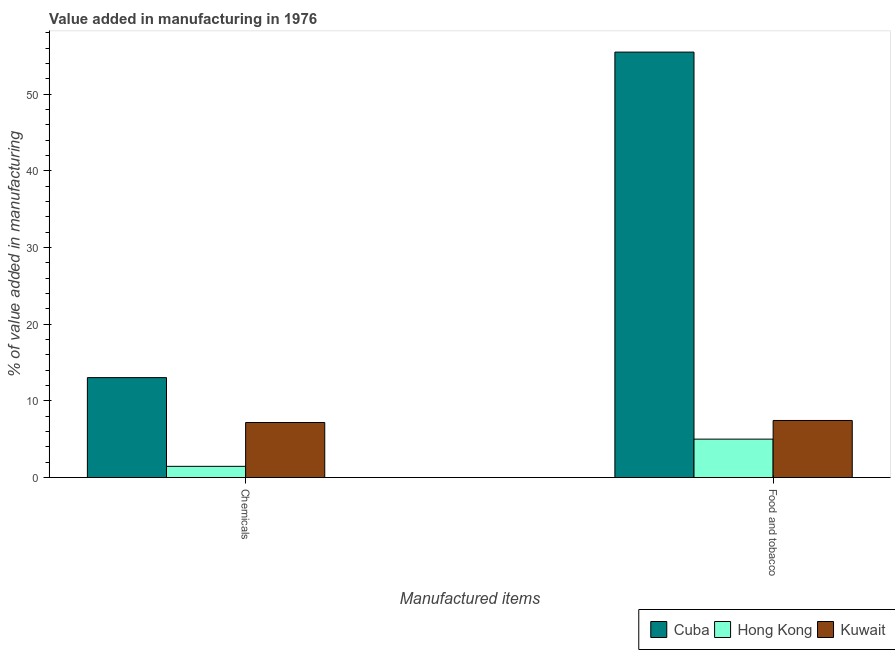How many groups of bars are there?
Provide a short and direct response. 2. How many bars are there on the 2nd tick from the right?
Ensure brevity in your answer.  3. What is the label of the 1st group of bars from the left?
Your answer should be very brief. Chemicals. What is the value added by  manufacturing chemicals in Hong Kong?
Ensure brevity in your answer.  1.46. Across all countries, what is the maximum value added by manufacturing food and tobacco?
Your answer should be compact. 55.47. Across all countries, what is the minimum value added by manufacturing food and tobacco?
Keep it short and to the point. 5.01. In which country was the value added by manufacturing food and tobacco maximum?
Give a very brief answer. Cuba. In which country was the value added by manufacturing food and tobacco minimum?
Provide a succinct answer. Hong Kong. What is the total value added by manufacturing food and tobacco in the graph?
Offer a very short reply. 67.92. What is the difference between the value added by  manufacturing chemicals in Cuba and that in Kuwait?
Give a very brief answer. 5.85. What is the difference between the value added by  manufacturing chemicals in Hong Kong and the value added by manufacturing food and tobacco in Cuba?
Provide a succinct answer. -54.01. What is the average value added by  manufacturing chemicals per country?
Keep it short and to the point. 7.22. What is the difference between the value added by  manufacturing chemicals and value added by manufacturing food and tobacco in Hong Kong?
Keep it short and to the point. -3.55. In how many countries, is the value added by manufacturing food and tobacco greater than 26 %?
Provide a short and direct response. 1. What is the ratio of the value added by  manufacturing chemicals in Kuwait to that in Cuba?
Your answer should be compact. 0.55. In how many countries, is the value added by manufacturing food and tobacco greater than the average value added by manufacturing food and tobacco taken over all countries?
Make the answer very short. 1. What does the 3rd bar from the left in Chemicals represents?
Offer a very short reply. Kuwait. What does the 2nd bar from the right in Food and tobacco represents?
Ensure brevity in your answer.  Hong Kong. What is the difference between two consecutive major ticks on the Y-axis?
Make the answer very short. 10. Are the values on the major ticks of Y-axis written in scientific E-notation?
Your answer should be very brief. No. Does the graph contain grids?
Provide a short and direct response. No. Where does the legend appear in the graph?
Offer a terse response. Bottom right. What is the title of the graph?
Offer a terse response. Value added in manufacturing in 1976. What is the label or title of the X-axis?
Keep it short and to the point. Manufactured items. What is the label or title of the Y-axis?
Keep it short and to the point. % of value added in manufacturing. What is the % of value added in manufacturing in Cuba in Chemicals?
Your answer should be very brief. 13.03. What is the % of value added in manufacturing in Hong Kong in Chemicals?
Ensure brevity in your answer.  1.46. What is the % of value added in manufacturing of Kuwait in Chemicals?
Your answer should be compact. 7.18. What is the % of value added in manufacturing in Cuba in Food and tobacco?
Make the answer very short. 55.47. What is the % of value added in manufacturing of Hong Kong in Food and tobacco?
Ensure brevity in your answer.  5.01. What is the % of value added in manufacturing in Kuwait in Food and tobacco?
Your answer should be compact. 7.44. Across all Manufactured items, what is the maximum % of value added in manufacturing in Cuba?
Keep it short and to the point. 55.47. Across all Manufactured items, what is the maximum % of value added in manufacturing of Hong Kong?
Your response must be concise. 5.01. Across all Manufactured items, what is the maximum % of value added in manufacturing in Kuwait?
Provide a short and direct response. 7.44. Across all Manufactured items, what is the minimum % of value added in manufacturing in Cuba?
Provide a short and direct response. 13.03. Across all Manufactured items, what is the minimum % of value added in manufacturing in Hong Kong?
Give a very brief answer. 1.46. Across all Manufactured items, what is the minimum % of value added in manufacturing of Kuwait?
Your response must be concise. 7.18. What is the total % of value added in manufacturing of Cuba in the graph?
Offer a terse response. 68.5. What is the total % of value added in manufacturing of Hong Kong in the graph?
Offer a terse response. 6.47. What is the total % of value added in manufacturing in Kuwait in the graph?
Keep it short and to the point. 14.62. What is the difference between the % of value added in manufacturing in Cuba in Chemicals and that in Food and tobacco?
Offer a very short reply. -42.44. What is the difference between the % of value added in manufacturing in Hong Kong in Chemicals and that in Food and tobacco?
Your answer should be compact. -3.55. What is the difference between the % of value added in manufacturing in Kuwait in Chemicals and that in Food and tobacco?
Ensure brevity in your answer.  -0.27. What is the difference between the % of value added in manufacturing of Cuba in Chemicals and the % of value added in manufacturing of Hong Kong in Food and tobacco?
Ensure brevity in your answer.  8.02. What is the difference between the % of value added in manufacturing in Cuba in Chemicals and the % of value added in manufacturing in Kuwait in Food and tobacco?
Your answer should be very brief. 5.58. What is the difference between the % of value added in manufacturing in Hong Kong in Chemicals and the % of value added in manufacturing in Kuwait in Food and tobacco?
Your answer should be compact. -5.98. What is the average % of value added in manufacturing of Cuba per Manufactured items?
Make the answer very short. 34.25. What is the average % of value added in manufacturing in Hong Kong per Manufactured items?
Your response must be concise. 3.24. What is the average % of value added in manufacturing in Kuwait per Manufactured items?
Give a very brief answer. 7.31. What is the difference between the % of value added in manufacturing of Cuba and % of value added in manufacturing of Hong Kong in Chemicals?
Offer a terse response. 11.56. What is the difference between the % of value added in manufacturing in Cuba and % of value added in manufacturing in Kuwait in Chemicals?
Give a very brief answer. 5.85. What is the difference between the % of value added in manufacturing of Hong Kong and % of value added in manufacturing of Kuwait in Chemicals?
Offer a terse response. -5.71. What is the difference between the % of value added in manufacturing in Cuba and % of value added in manufacturing in Hong Kong in Food and tobacco?
Your answer should be compact. 50.46. What is the difference between the % of value added in manufacturing of Cuba and % of value added in manufacturing of Kuwait in Food and tobacco?
Make the answer very short. 48.02. What is the difference between the % of value added in manufacturing in Hong Kong and % of value added in manufacturing in Kuwait in Food and tobacco?
Your answer should be very brief. -2.43. What is the ratio of the % of value added in manufacturing of Cuba in Chemicals to that in Food and tobacco?
Make the answer very short. 0.23. What is the ratio of the % of value added in manufacturing of Hong Kong in Chemicals to that in Food and tobacco?
Give a very brief answer. 0.29. What is the ratio of the % of value added in manufacturing of Kuwait in Chemicals to that in Food and tobacco?
Ensure brevity in your answer.  0.96. What is the difference between the highest and the second highest % of value added in manufacturing of Cuba?
Your answer should be very brief. 42.44. What is the difference between the highest and the second highest % of value added in manufacturing in Hong Kong?
Offer a very short reply. 3.55. What is the difference between the highest and the second highest % of value added in manufacturing in Kuwait?
Your answer should be very brief. 0.27. What is the difference between the highest and the lowest % of value added in manufacturing in Cuba?
Provide a succinct answer. 42.44. What is the difference between the highest and the lowest % of value added in manufacturing in Hong Kong?
Make the answer very short. 3.55. What is the difference between the highest and the lowest % of value added in manufacturing of Kuwait?
Offer a very short reply. 0.27. 